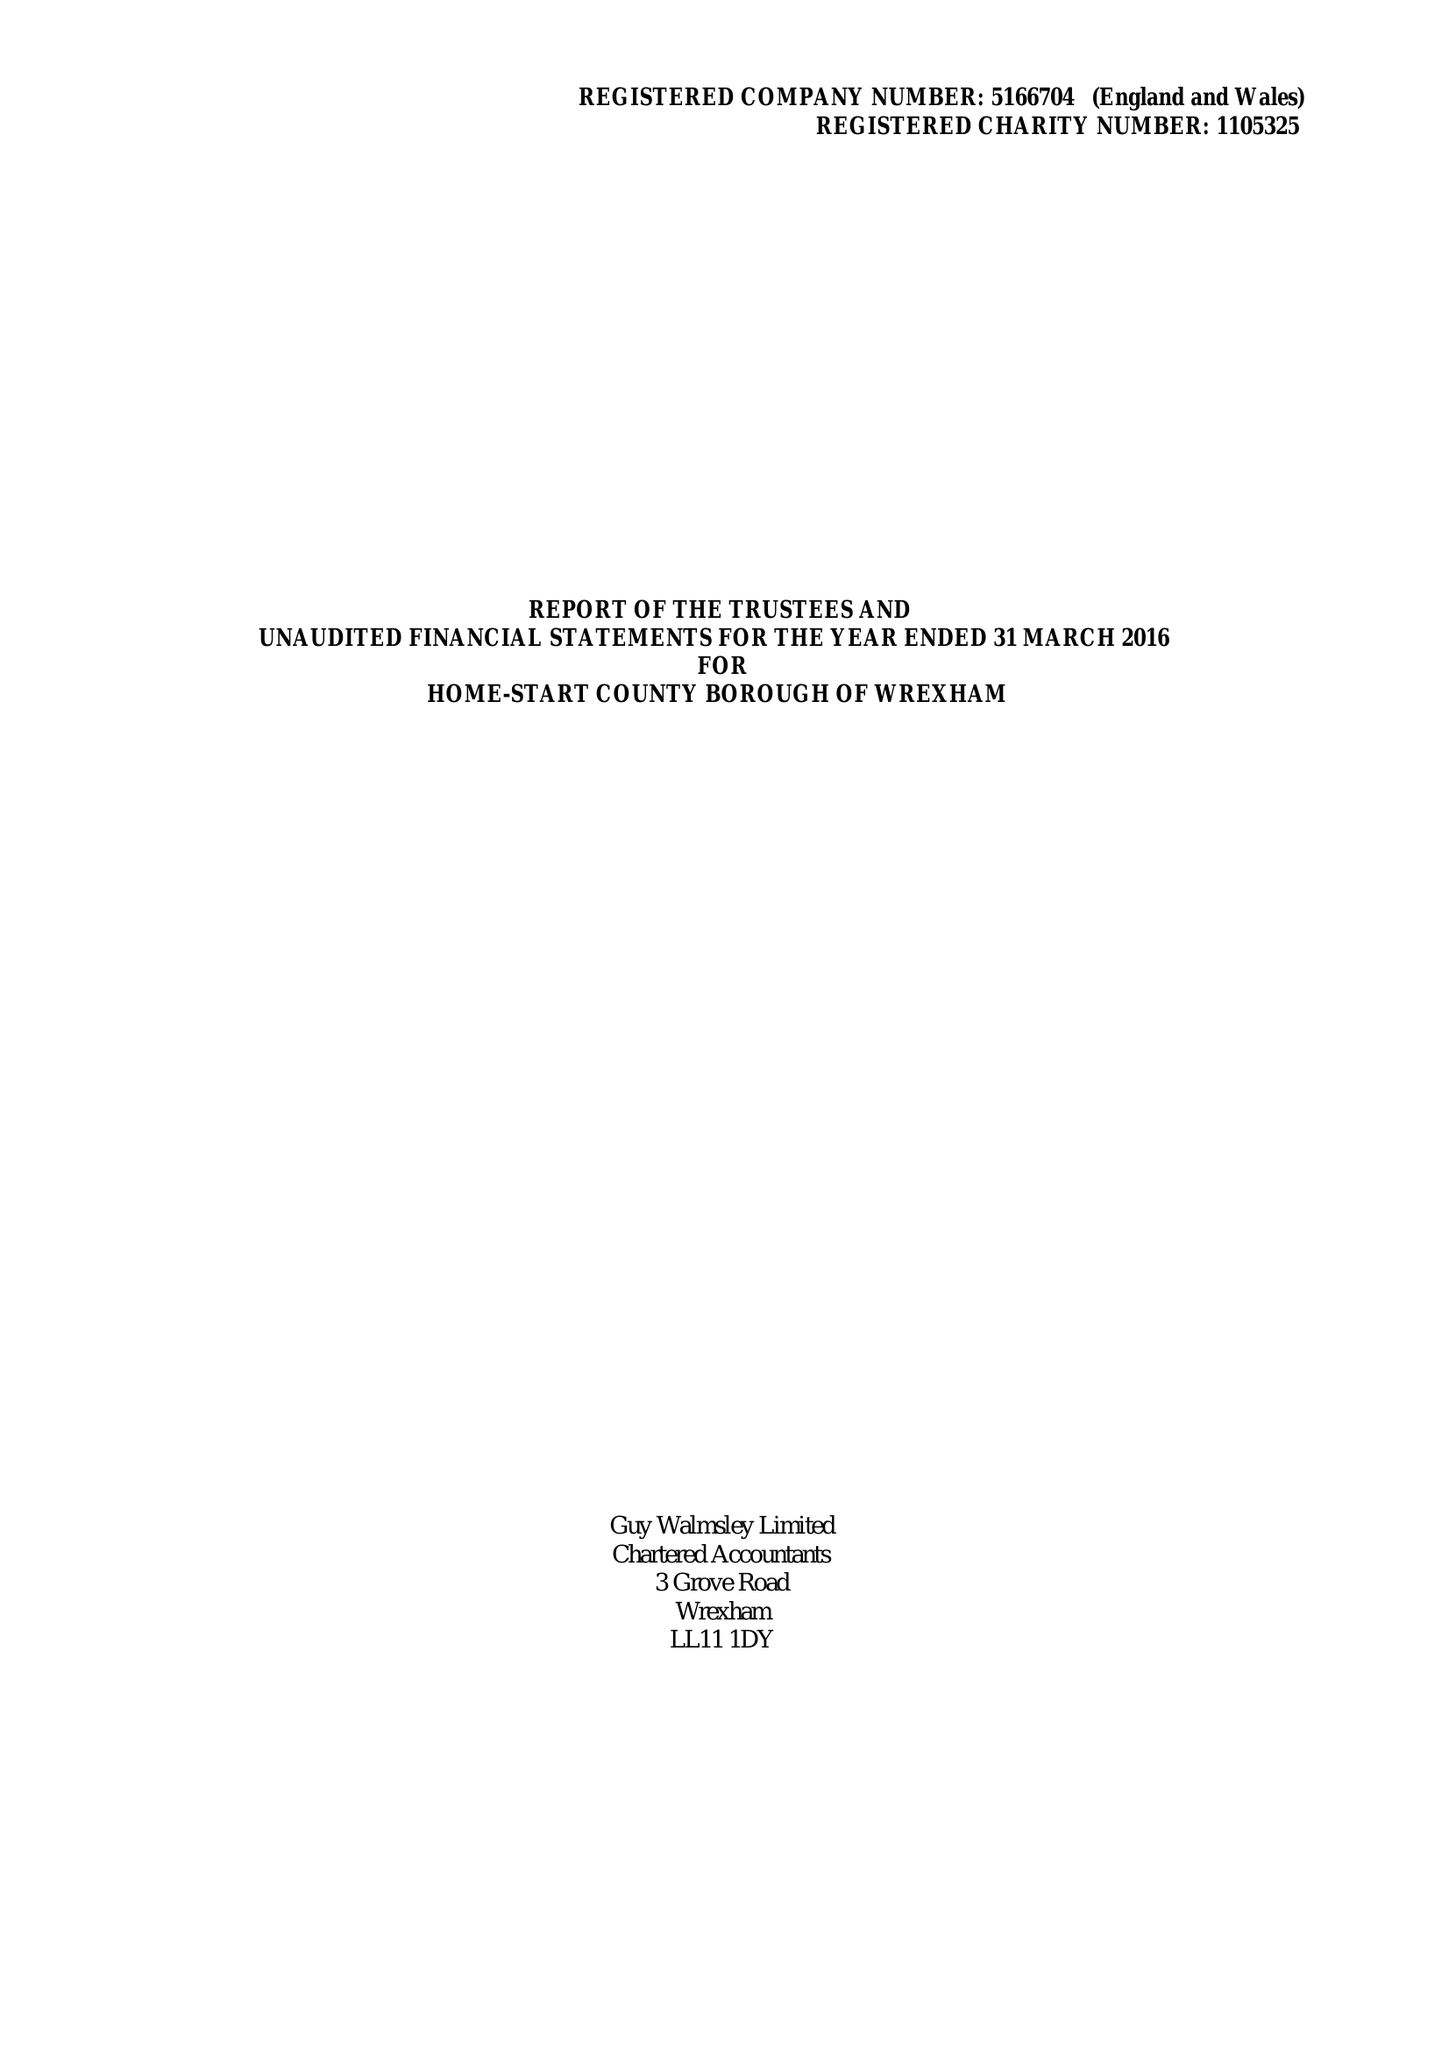What is the value for the address__post_town?
Answer the question using a single word or phrase. WREXHAM 